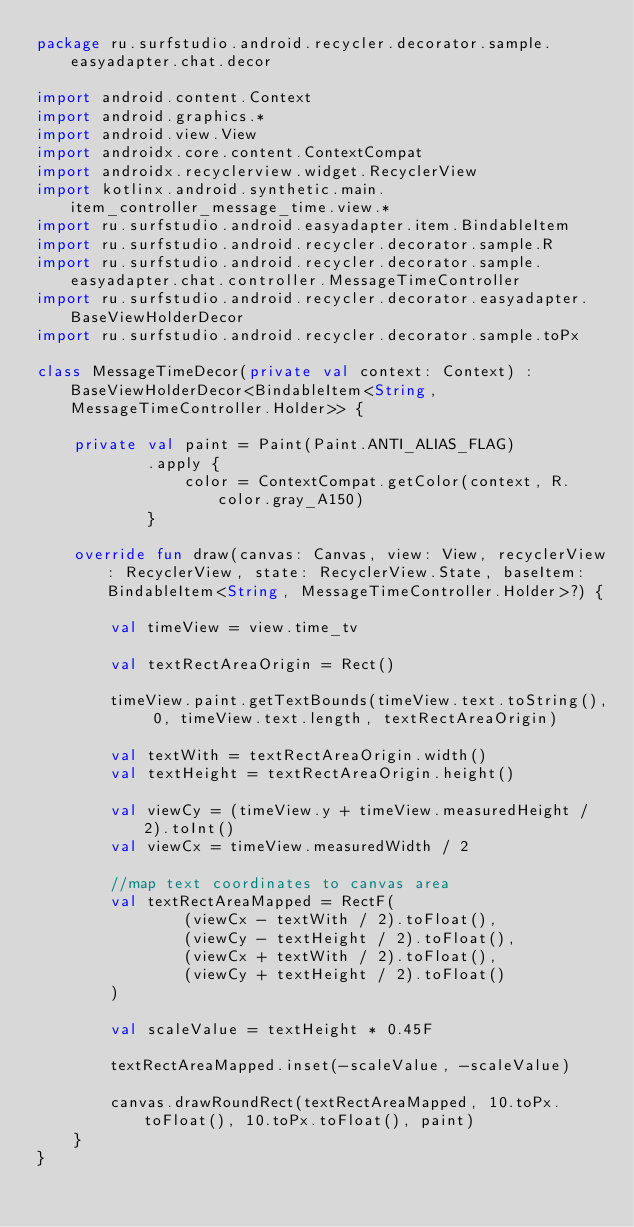<code> <loc_0><loc_0><loc_500><loc_500><_Kotlin_>package ru.surfstudio.android.recycler.decorator.sample.easyadapter.chat.decor

import android.content.Context
import android.graphics.*
import android.view.View
import androidx.core.content.ContextCompat
import androidx.recyclerview.widget.RecyclerView
import kotlinx.android.synthetic.main.item_controller_message_time.view.*
import ru.surfstudio.android.easyadapter.item.BindableItem
import ru.surfstudio.android.recycler.decorator.sample.R
import ru.surfstudio.android.recycler.decorator.sample.easyadapter.chat.controller.MessageTimeController
import ru.surfstudio.android.recycler.decorator.easyadapter.BaseViewHolderDecor
import ru.surfstudio.android.recycler.decorator.sample.toPx

class MessageTimeDecor(private val context: Context) : BaseViewHolderDecor<BindableItem<String, MessageTimeController.Holder>> {

    private val paint = Paint(Paint.ANTI_ALIAS_FLAG)
            .apply {
                color = ContextCompat.getColor(context, R.color.gray_A150)
            }

    override fun draw(canvas: Canvas, view: View, recyclerView: RecyclerView, state: RecyclerView.State, baseItem: BindableItem<String, MessageTimeController.Holder>?) {

        val timeView = view.time_tv

        val textRectAreaOrigin = Rect()

        timeView.paint.getTextBounds(timeView.text.toString(), 0, timeView.text.length, textRectAreaOrigin)

        val textWith = textRectAreaOrigin.width()
        val textHeight = textRectAreaOrigin.height()

        val viewCy = (timeView.y + timeView.measuredHeight / 2).toInt()
        val viewCx = timeView.measuredWidth / 2

        //map text coordinates to canvas area
        val textRectAreaMapped = RectF(
                (viewCx - textWith / 2).toFloat(),
                (viewCy - textHeight / 2).toFloat(),
                (viewCx + textWith / 2).toFloat(),
                (viewCy + textHeight / 2).toFloat()
        )

        val scaleValue = textHeight * 0.45F

        textRectAreaMapped.inset(-scaleValue, -scaleValue)

        canvas.drawRoundRect(textRectAreaMapped, 10.toPx.toFloat(), 10.toPx.toFloat(), paint)
    }
}</code> 